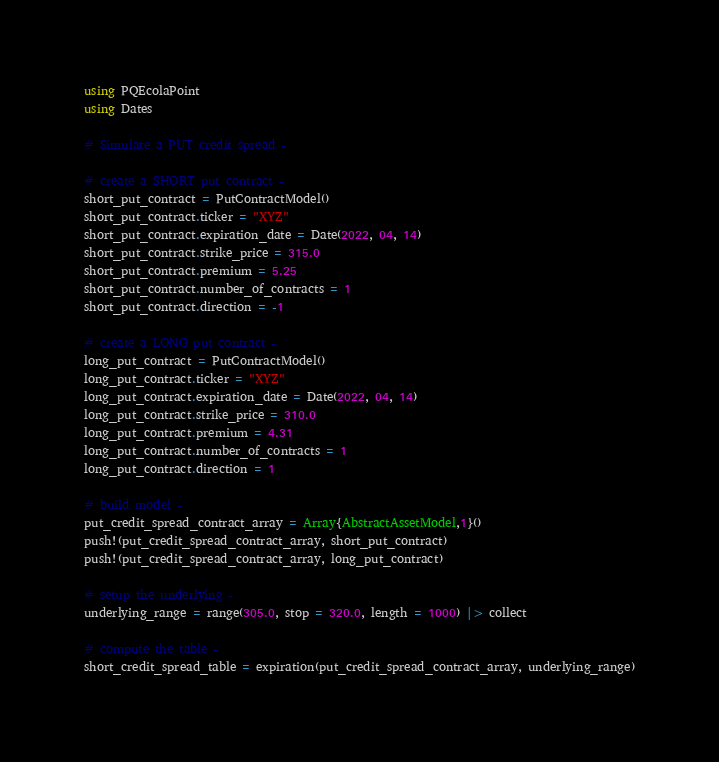<code> <loc_0><loc_0><loc_500><loc_500><_Julia_>using PQEcolaPoint
using Dates

# Simulate a PUT credit spread -

# create a SHORT put contract -
short_put_contract = PutContractModel()
short_put_contract.ticker = "XYZ"
short_put_contract.expiration_date = Date(2022, 04, 14)
short_put_contract.strike_price = 315.0
short_put_contract.premium = 5.25
short_put_contract.number_of_contracts = 1
short_put_contract.direction = -1

# create a LONG put contract -
long_put_contract = PutContractModel()
long_put_contract.ticker = "XYZ"
long_put_contract.expiration_date = Date(2022, 04, 14)
long_put_contract.strike_price = 310.0
long_put_contract.premium = 4.31
long_put_contract.number_of_contracts = 1
long_put_contract.direction = 1

# build model -
put_credit_spread_contract_array = Array{AbstractAssetModel,1}()
push!(put_credit_spread_contract_array, short_put_contract)
push!(put_credit_spread_contract_array, long_put_contract)

# setup the underlying -
underlying_range = range(305.0, stop = 320.0, length = 1000) |> collect

# compute the table -
short_credit_spread_table = expiration(put_credit_spread_contract_array, underlying_range)
</code> 